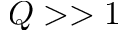<formula> <loc_0><loc_0><loc_500><loc_500>Q > > 1</formula> 